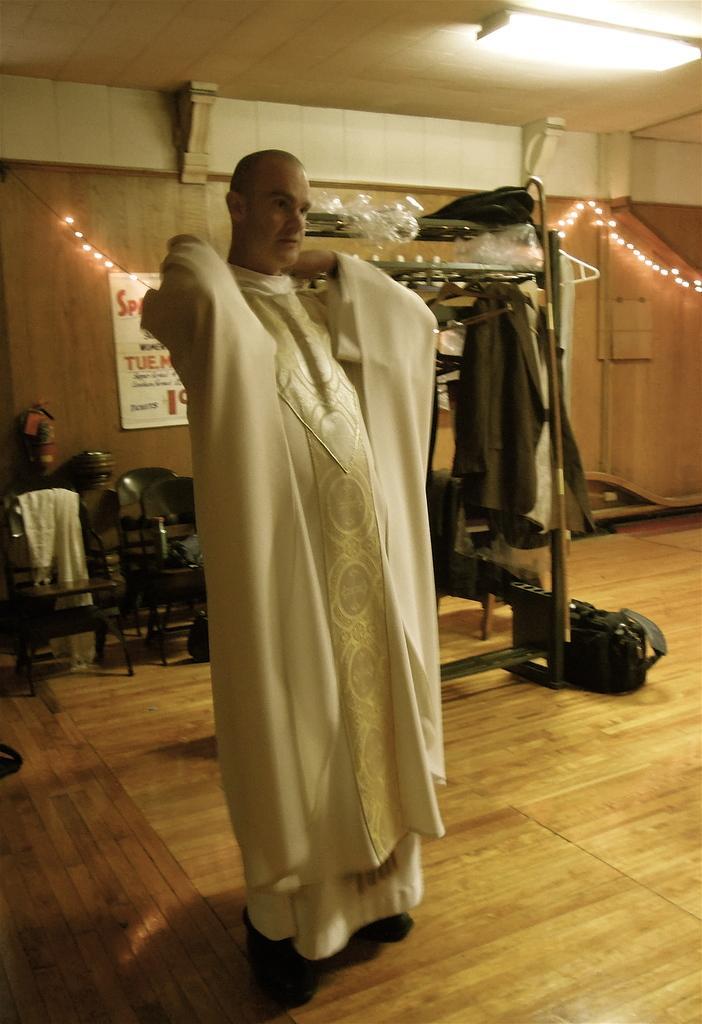In one or two sentences, can you explain what this image depicts? There is a person wearing a white dress. In the back there are chairs. Also there is a stand with hanger and dress. On the floor there are bags. In the back there is a wall with light decorations. On the wall there is a poster and a fire extinguisher. On the ceiling there is light. 